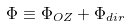Convert formula to latex. <formula><loc_0><loc_0><loc_500><loc_500>\Phi \equiv \Phi _ { O Z } + \Phi _ { d i r }</formula> 